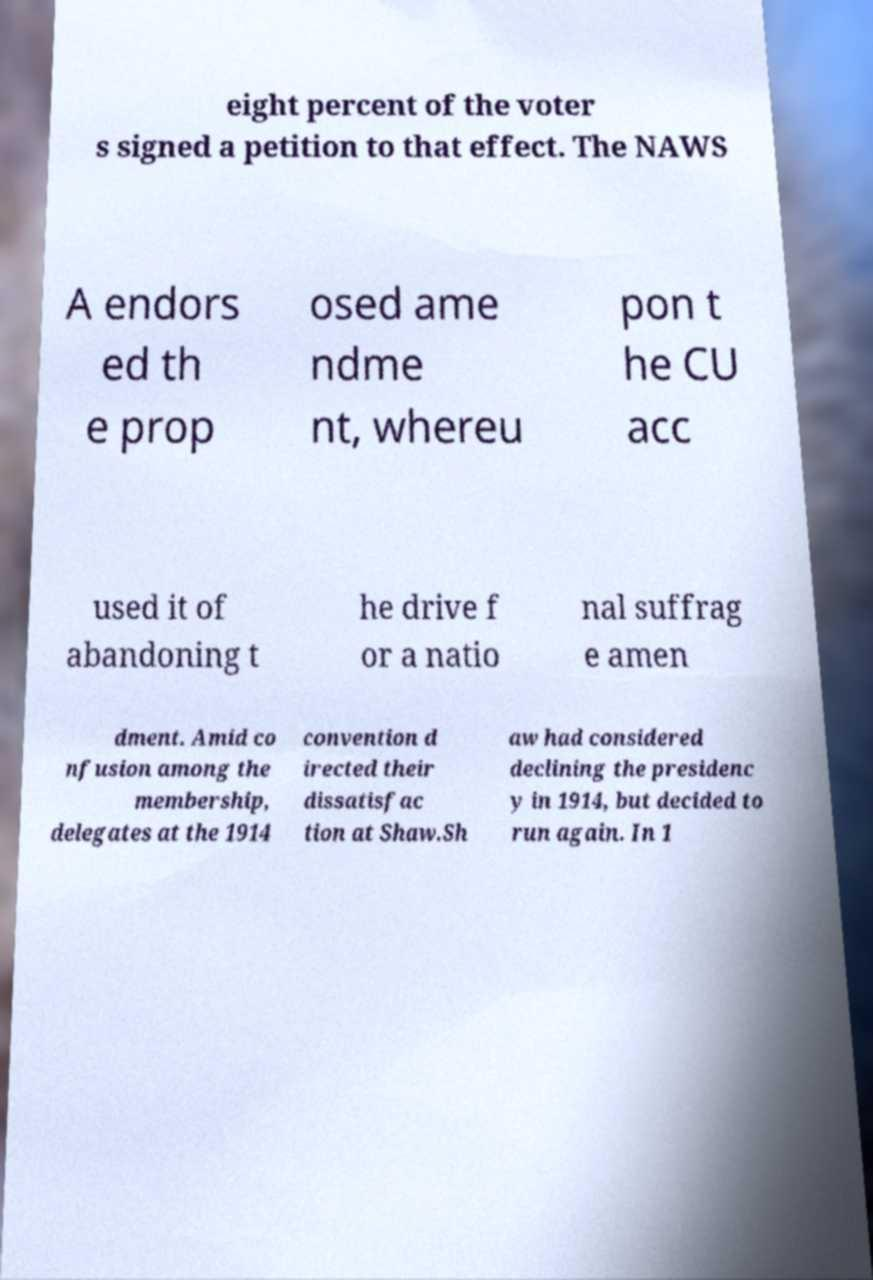Can you read and provide the text displayed in the image?This photo seems to have some interesting text. Can you extract and type it out for me? eight percent of the voter s signed a petition to that effect. The NAWS A endors ed th e prop osed ame ndme nt, whereu pon t he CU acc used it of abandoning t he drive f or a natio nal suffrag e amen dment. Amid co nfusion among the membership, delegates at the 1914 convention d irected their dissatisfac tion at Shaw.Sh aw had considered declining the presidenc y in 1914, but decided to run again. In 1 